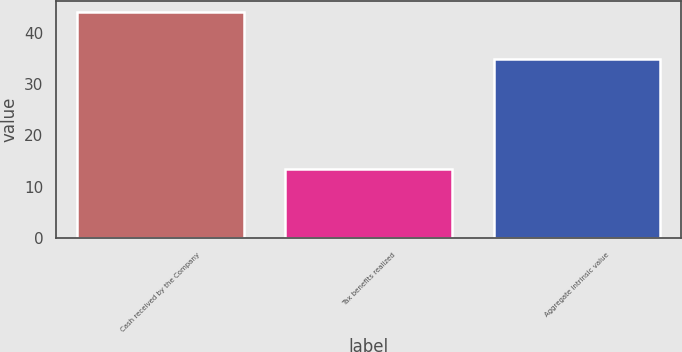Convert chart to OTSL. <chart><loc_0><loc_0><loc_500><loc_500><bar_chart><fcel>Cash received by the Company<fcel>Tax benefits realized<fcel>Aggregate intrinsic value<nl><fcel>43.9<fcel>13.4<fcel>34.8<nl></chart> 